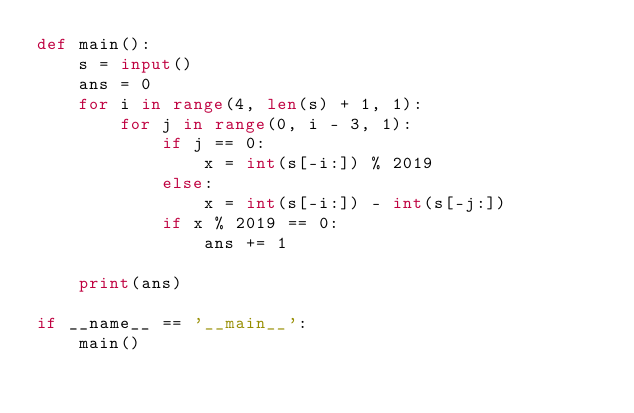Convert code to text. <code><loc_0><loc_0><loc_500><loc_500><_Python_>def main():
    s = input()
    ans = 0
    for i in range(4, len(s) + 1, 1):
        for j in range(0, i - 3, 1):
            if j == 0:
                x = int(s[-i:]) % 2019
            else:
                x = int(s[-i:]) - int(s[-j:])
            if x % 2019 == 0:
                ans += 1

    print(ans)

if __name__ == '__main__':
    main()
</code> 